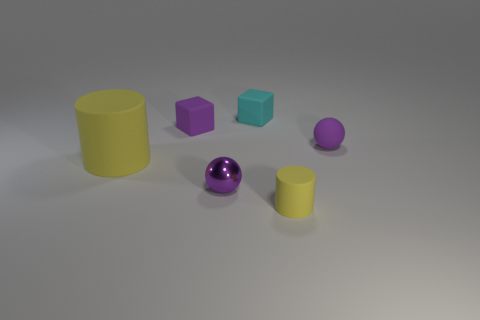Is the number of small matte things that are left of the small purple metallic ball greater than the number of large metal cubes?
Ensure brevity in your answer.  Yes. There is a matte cylinder that is in front of the purple shiny object; what is its color?
Give a very brief answer. Yellow. There is a cylinder that is the same color as the big rubber object; what size is it?
Offer a terse response. Small. What number of rubber things are either cyan blocks or large yellow cylinders?
Provide a succinct answer. 2. There is a yellow object in front of the small purple shiny object that is in front of the purple rubber block; are there any tiny purple objects on the right side of it?
Your answer should be compact. Yes. There is a tiny purple metallic thing; what number of small balls are behind it?
Ensure brevity in your answer.  1. There is another ball that is the same color as the tiny rubber ball; what is it made of?
Ensure brevity in your answer.  Metal. How many small things are either yellow matte balls or rubber blocks?
Your answer should be compact. 2. There is a rubber object that is on the left side of the purple cube; what shape is it?
Your response must be concise. Cylinder. Is there a tiny matte ball that has the same color as the big matte cylinder?
Your answer should be compact. No. 